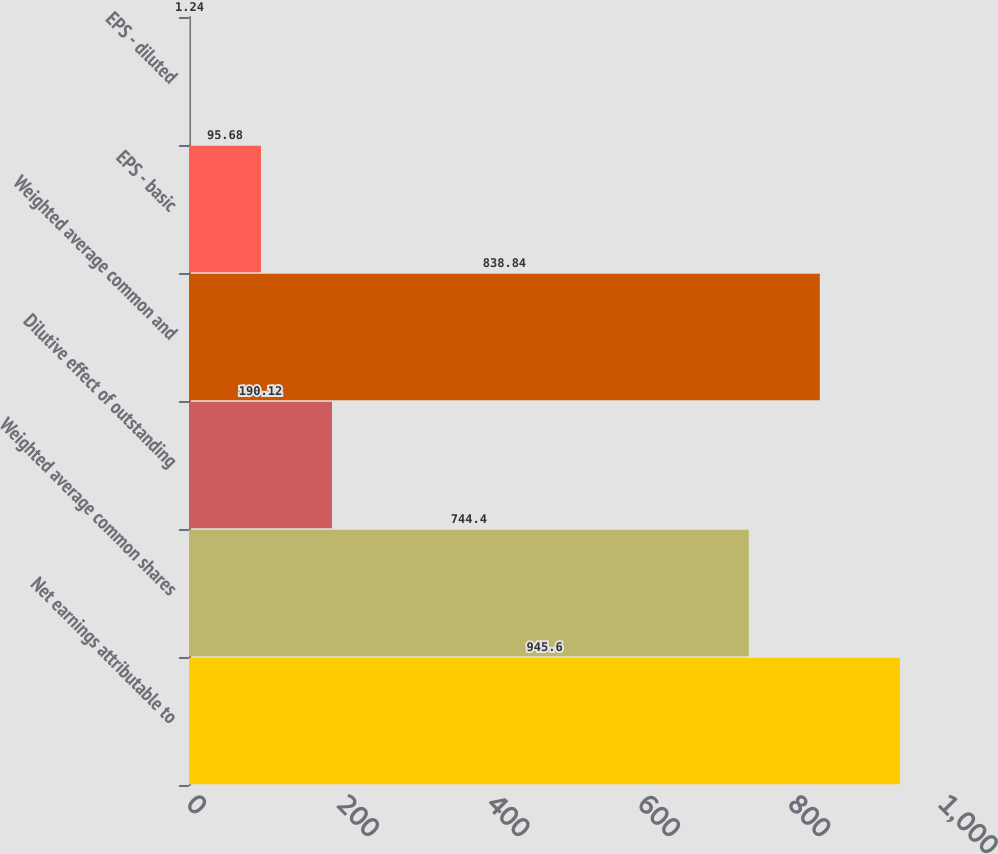<chart> <loc_0><loc_0><loc_500><loc_500><bar_chart><fcel>Net earnings attributable to<fcel>Weighted average common shares<fcel>Dilutive effect of outstanding<fcel>Weighted average common and<fcel>EPS - basic<fcel>EPS - diluted<nl><fcel>945.6<fcel>744.4<fcel>190.12<fcel>838.84<fcel>95.68<fcel>1.24<nl></chart> 